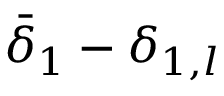<formula> <loc_0><loc_0><loc_500><loc_500>\bar { \delta } _ { 1 } - \delta _ { 1 , l }</formula> 